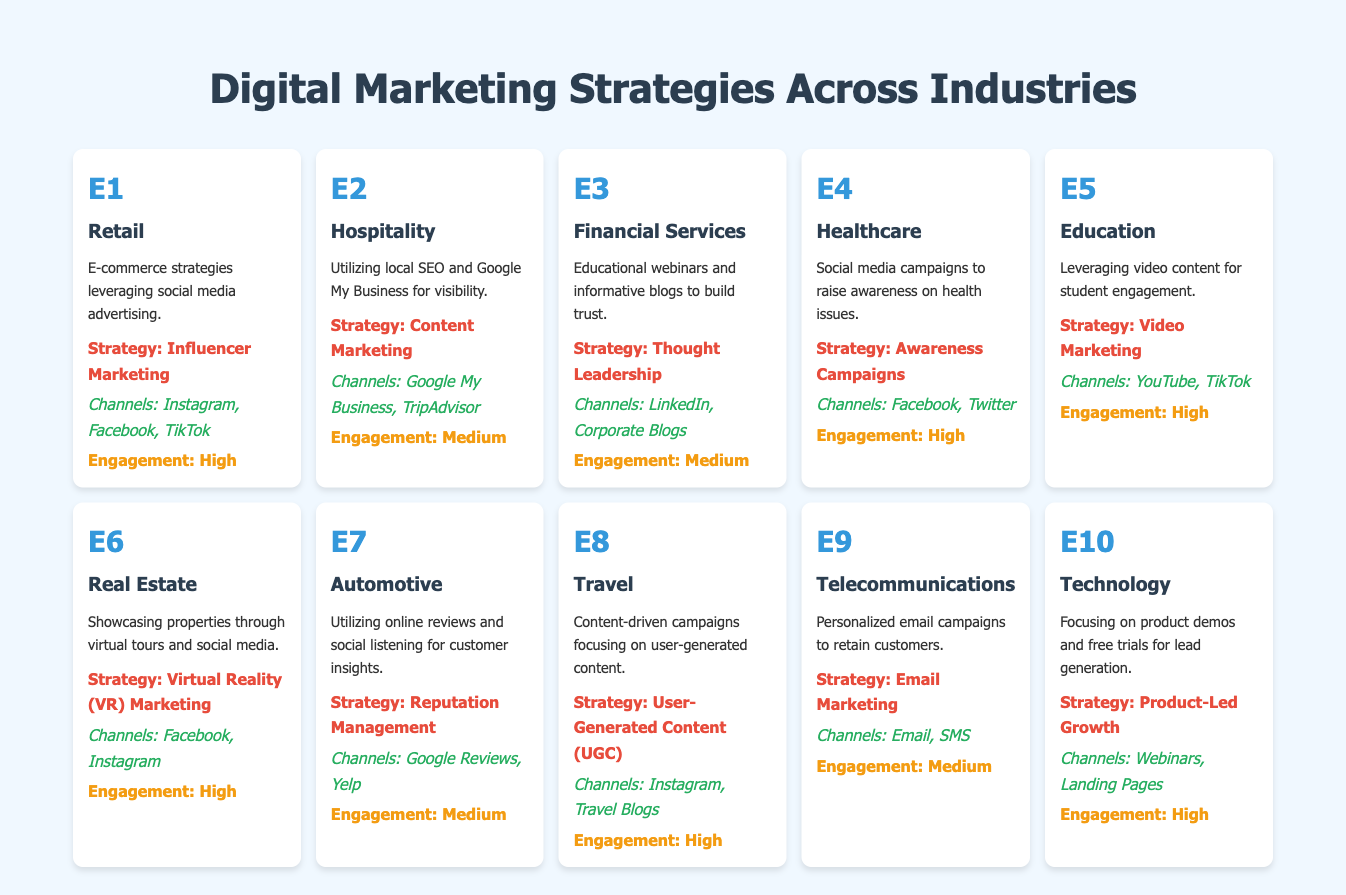What is the primary marketing strategy used by the Healthcare industry? The Healthcare industry uses "Awareness Campaigns" as its primary marketing strategy, as stated in the table.
Answer: Awareness Campaigns Which industry utilizes Email Marketing as a strategy? The Telecommunications industry utilizes Email Marketing as its primary strategy according to the table.
Answer: Telecommunications How many industries have a high engagement level? There are 5 industries with high engagement levels: Retail, Healthcare, Education, Real Estate, Travel, and Technology. Counting these gives us 6 industries total.
Answer: 6 What is the main marketing channel for the Automotive industry? The main marketing channels for the Automotive industry are "Google Reviews" and "Yelp" according to the table's listed channels for that industry.
Answer: Google Reviews and Yelp Does the Financial Services industry have a high engagement level? No, the Financial Services industry has a medium engagement level as per the engagement rating in the table.
Answer: No Which industries use social media platforms for their marketing strategies? The industries that use social media for their marketing strategies include Retail, Healthcare, Real Estate, Travel, and Telecommunications. Combining these industries shows that a total of 5 do.
Answer: 5 Which industry among those listed employs User-Generated Content as part of their marketing strategy? The Travel industry employs User-Generated Content as part of its marketing strategy, as indicated in the table.
Answer: Travel What is the strategy of the Education industry and what are its primary channels? The Education industry employs "Video Marketing," and the primary channels used include "YouTube" and "TikTok" according to the information provided in the table.
Answer: Video Marketing; YouTube, TikTok How does the engagement level of the Hospitality industry compare to that of the Retail industry? The Hospitality industry has a medium engagement level, while the Retail industry enjoys a high engagement level. Therefore, the Retail industry's engagement level is higher.
Answer: Retail's engagement is higher 